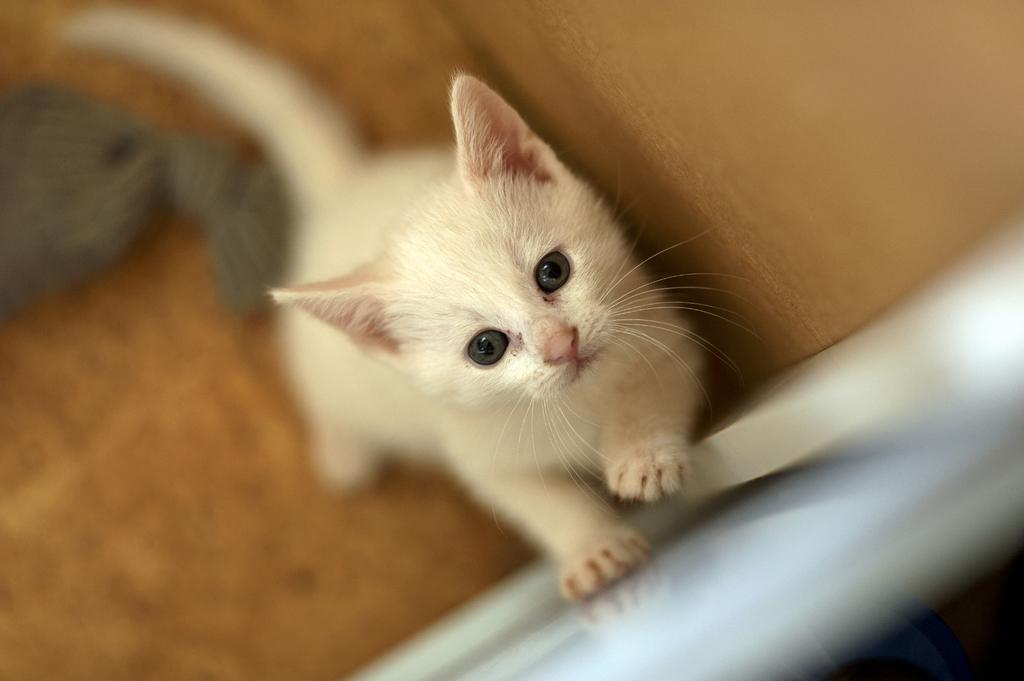What type of animal is in the image? There is a white color cat in the image. How is the cat positioned in the image? The cat is standing on one leg. What is the cat doing with its other legs? The cat has one leg on another surface. Can you describe the background of the image? The background of the image is blurred. What type of net is being used by the government in the image? There is no net or reference to the government present in the image. 